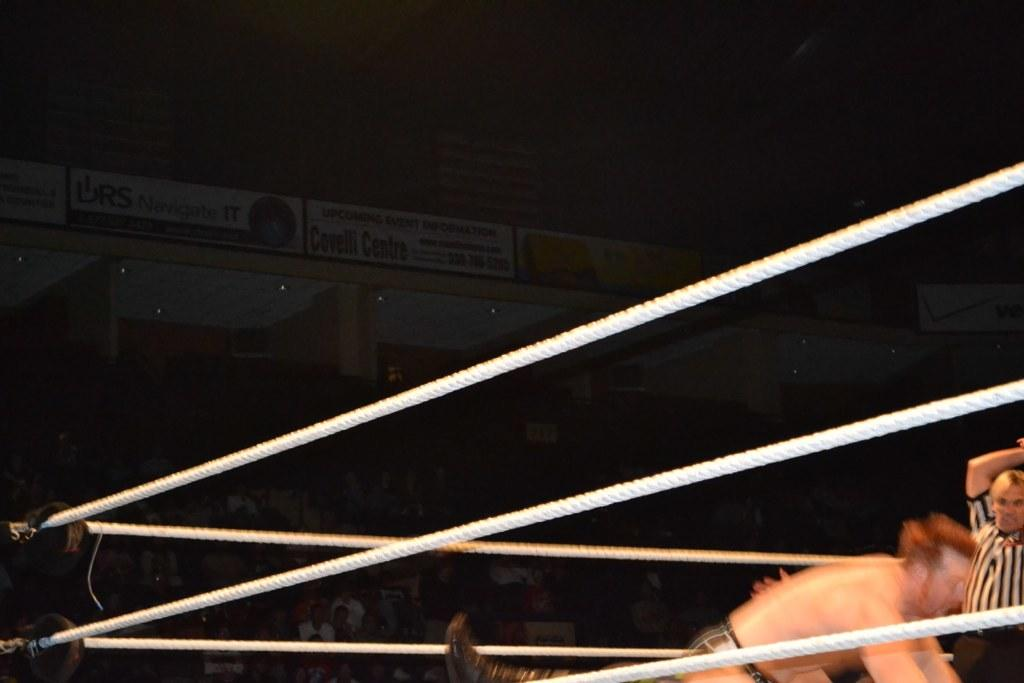What are the two persons in the image doing? The two persons in the image are playing a game. What color are the ropes in the image? The ropes in the image are white. What can be seen in the background of the image? There is a group of people sitting and boards visible in the background of the image. What type of notebook is being used by one of the persons playing the game in the image? There is no notebook present in the image; the two persons are playing a game with ropes. 